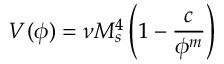<formula> <loc_0><loc_0><loc_500><loc_500>V ( \phi ) = \nu M _ { s } ^ { 4 } \left ( 1 - \frac { c } { \phi ^ { m } } \right )</formula> 